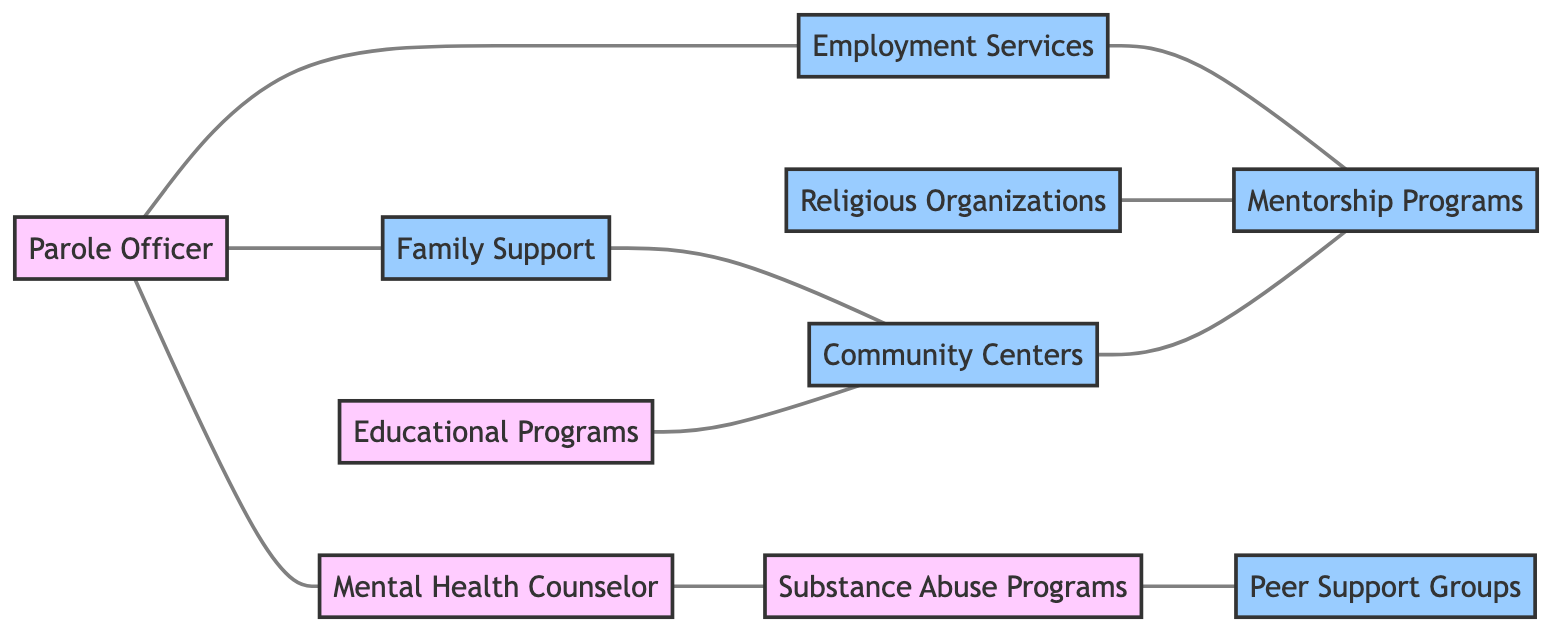What is the total number of nodes in the diagram? The diagram contains the following nodes: Parole Officer, Family Support, Employment Services, Mental Health Counselor, Substance Abuse Programs, Educational Programs, Religious Organizations, Community Centers, Mentorship Programs, and Peer Support Groups. Counting these nodes gives us a total of 10.
Answer: 10 Which node is connected to Family Support? Family Support has a direct connection to Community Centers, as indicated by the edge in the diagram. This means that Family Support and Community Centers are directly related.
Answer: Community Centers How many edges are there in total in the diagram? The edges present represent the connections between different nodes. Counting all edges listed shows that there are 9 distinct edges in the diagram.
Answer: 9 Which program is associated with substance abuse? The Mental Health Counselor has a direct connection to Substance Abuse Programs, indicating that they are linked, and the support structure for treating substance abuse issues is provided by these programs.
Answer: Mental Health Counselor What connections does the Employment Services node have? Employment Services is connected to three nodes directly: Parole Officer, Mentorship Programs, and this indicates that Employment Services faculty a relationship involving support and guidance back to the parole system and mentorship for reintegration.
Answer: Parole Officer, Mentorship Programs Which community program supports mentorship? The diagram indicates that both Employment Services and Community Centers are connected to Mentorship Programs, showcasing the relationships between these nodes and their role in providing mentorship support.
Answer: Employment Services, Community Centers Which community support is connected to Peer Support Groups? The Substance Abuse Programs have a direct connection to Peer Support Groups, suggesting that these groups are a way for individuals to share experiences and support each other in recovery from substance abuse.
Answer: Substance Abuse Programs Which types of organizations are classified as institutions in this diagram? In the diagram, the nodes classified as institutions include Parole Officer, Mental Health Counselor, Substance Abuse Programs, and Educational Programs, indicating their roles as formal support systems in the rehabilitation process.
Answer: Parole Officer, Mental Health Counselor, Substance Abuse Programs, Educational Programs What is the relationship between Religious Organizations and Mentorship Programs? The diagram shows a direct connection between Religious Organizations and Mentorship Programs, indicating that religious groups may provide mentorship opportunities to help individuals in their process of rehabilitation.
Answer: Mentorship Programs 